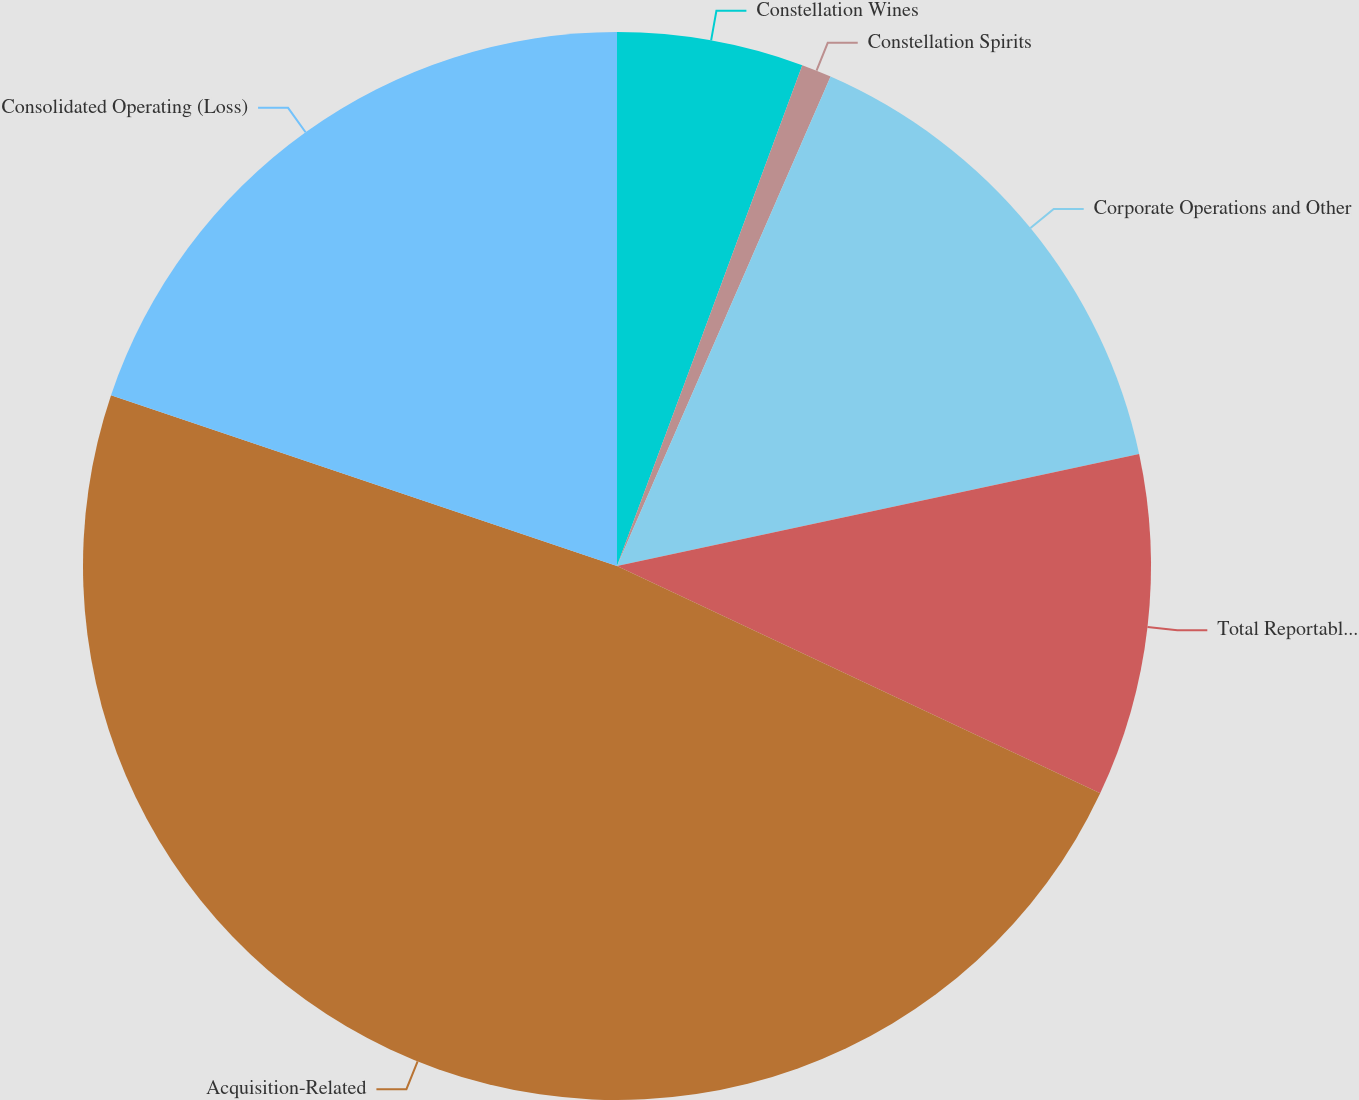Convert chart to OTSL. <chart><loc_0><loc_0><loc_500><loc_500><pie_chart><fcel>Constellation Wines<fcel>Constellation Spirits<fcel>Corporate Operations and Other<fcel>Total Reportable Segments<fcel>Acquisition-Related<fcel>Consolidated Operating (Loss)<nl><fcel>5.64%<fcel>0.91%<fcel>15.09%<fcel>10.36%<fcel>48.18%<fcel>19.82%<nl></chart> 